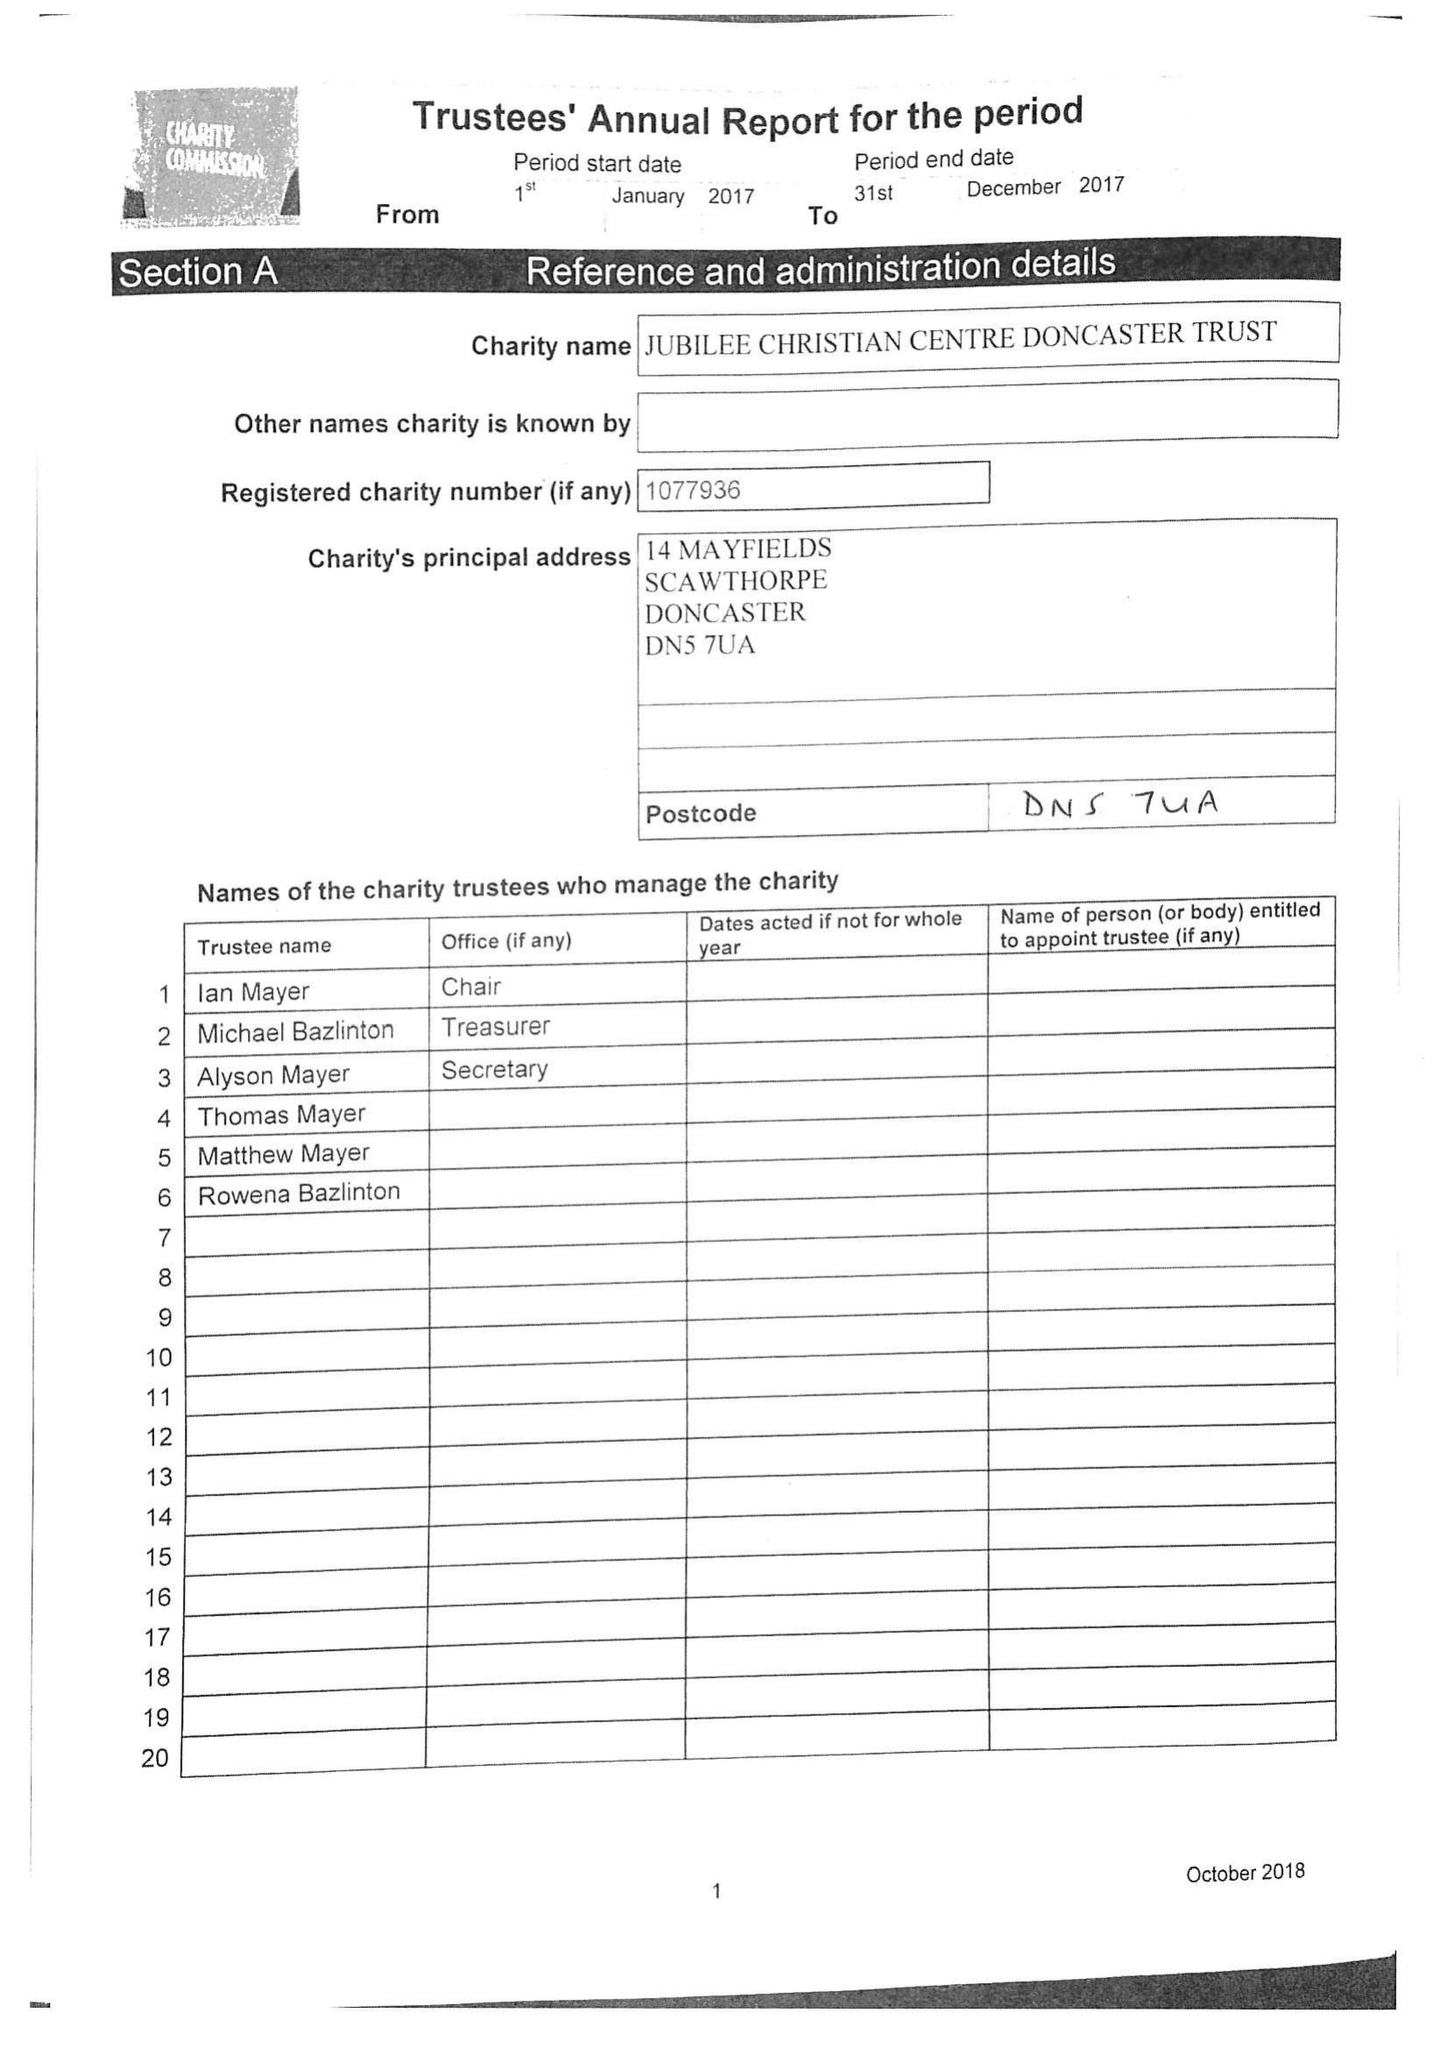What is the value for the address__street_line?
Answer the question using a single word or phrase. 14 MAYFIELDS 